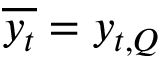Convert formula to latex. <formula><loc_0><loc_0><loc_500><loc_500>\overline { { y _ { t } } } = y _ { t , Q }</formula> 